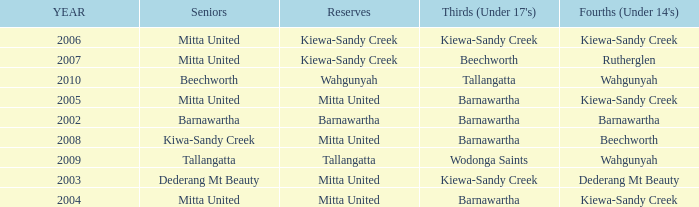Which Fourths (Under 14's) have Seniors of dederang mt beauty? Dederang Mt Beauty. 